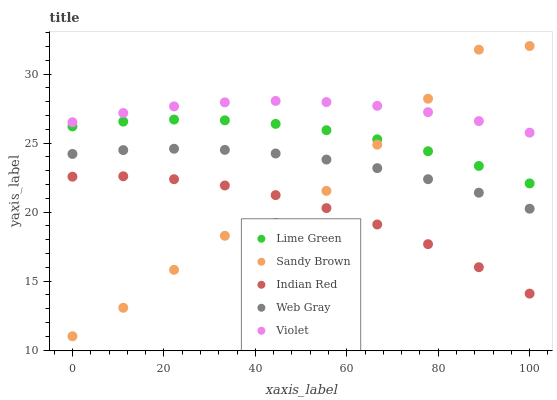Does Indian Red have the minimum area under the curve?
Answer yes or no. Yes. Does Violet have the maximum area under the curve?
Answer yes or no. Yes. Does Web Gray have the minimum area under the curve?
Answer yes or no. No. Does Web Gray have the maximum area under the curve?
Answer yes or no. No. Is Web Gray the smoothest?
Answer yes or no. Yes. Is Sandy Brown the roughest?
Answer yes or no. Yes. Is Lime Green the smoothest?
Answer yes or no. No. Is Lime Green the roughest?
Answer yes or no. No. Does Sandy Brown have the lowest value?
Answer yes or no. Yes. Does Web Gray have the lowest value?
Answer yes or no. No. Does Sandy Brown have the highest value?
Answer yes or no. Yes. Does Web Gray have the highest value?
Answer yes or no. No. Is Indian Red less than Lime Green?
Answer yes or no. Yes. Is Web Gray greater than Indian Red?
Answer yes or no. Yes. Does Lime Green intersect Sandy Brown?
Answer yes or no. Yes. Is Lime Green less than Sandy Brown?
Answer yes or no. No. Is Lime Green greater than Sandy Brown?
Answer yes or no. No. Does Indian Red intersect Lime Green?
Answer yes or no. No. 